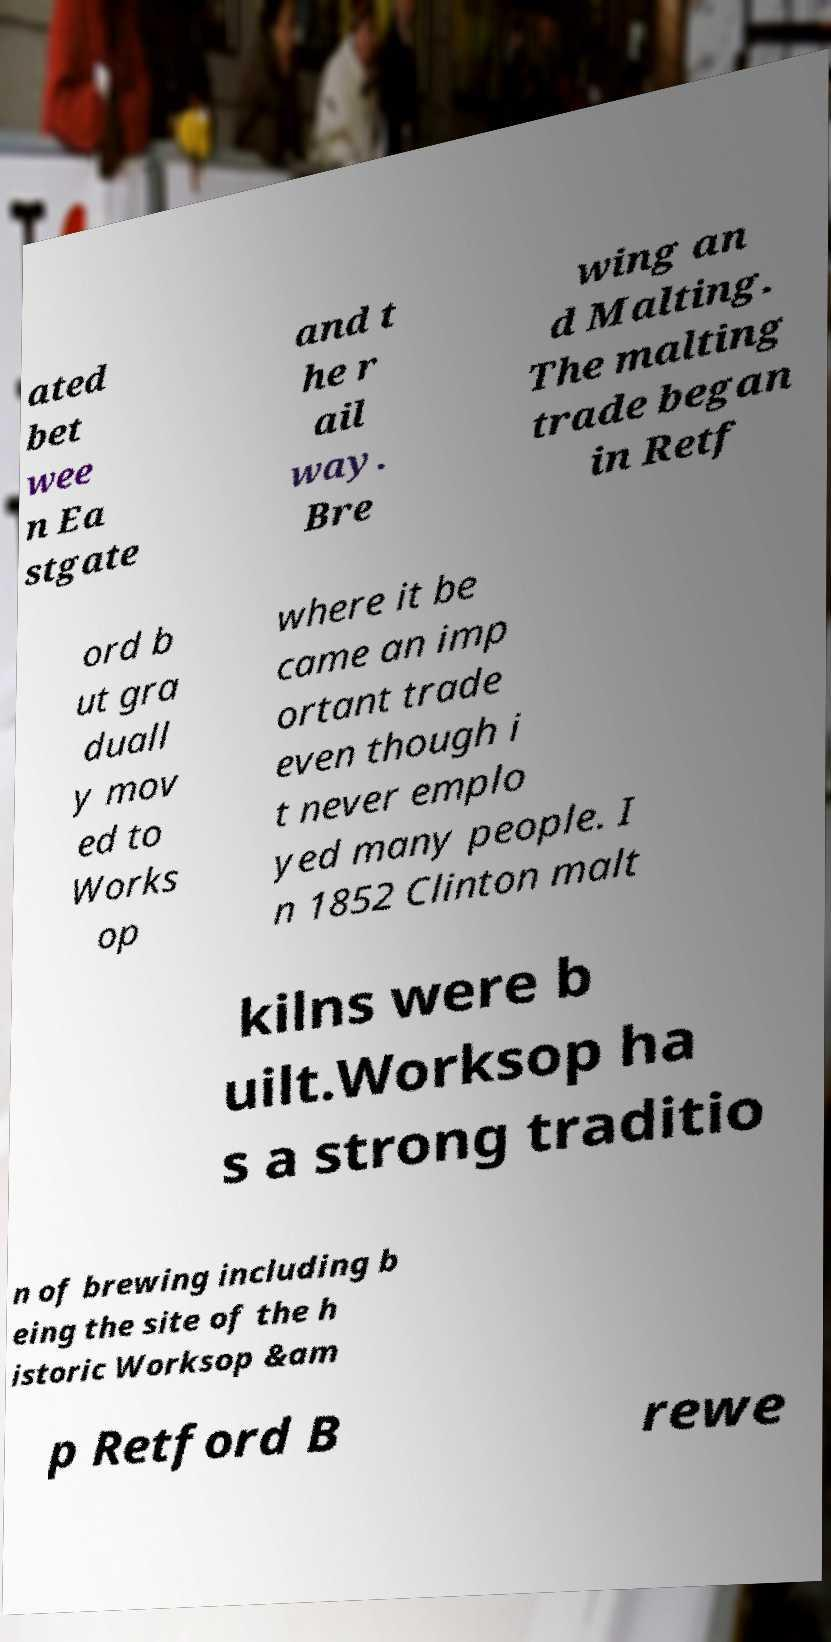Could you extract and type out the text from this image? ated bet wee n Ea stgate and t he r ail way. Bre wing an d Malting. The malting trade began in Retf ord b ut gra duall y mov ed to Works op where it be came an imp ortant trade even though i t never emplo yed many people. I n 1852 Clinton malt kilns were b uilt.Worksop ha s a strong traditio n of brewing including b eing the site of the h istoric Worksop &am p Retford B rewe 